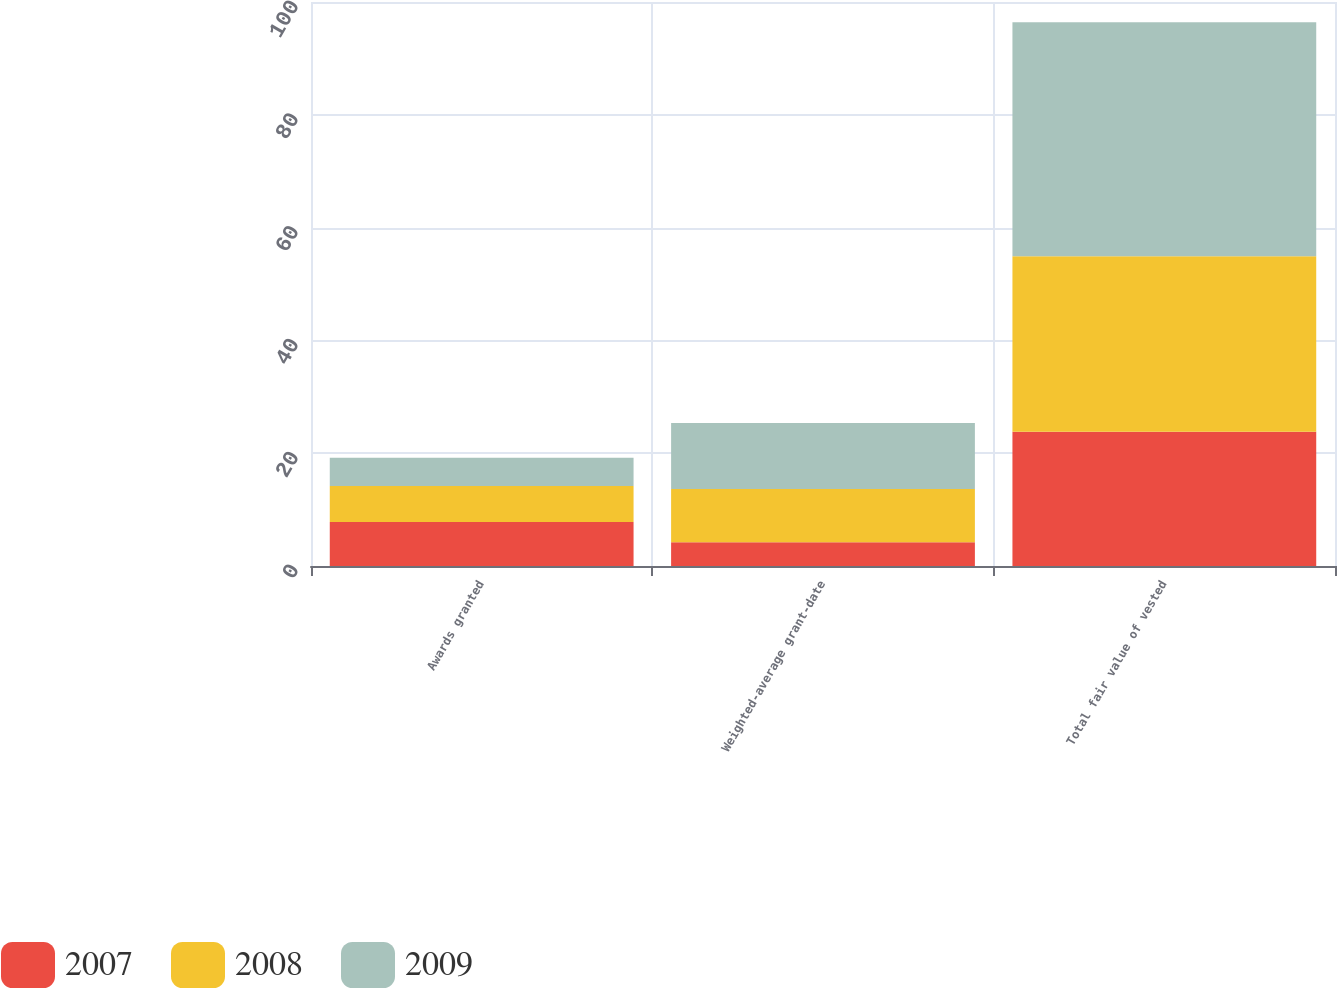Convert chart to OTSL. <chart><loc_0><loc_0><loc_500><loc_500><stacked_bar_chart><ecel><fcel>Awards granted<fcel>Weighted-average grant-date<fcel>Total fair value of vested<nl><fcel>2007<fcel>7.8<fcel>4.21<fcel>23.8<nl><fcel>2008<fcel>6.4<fcel>9.46<fcel>31.1<nl><fcel>2009<fcel>5<fcel>11.68<fcel>41.5<nl></chart> 